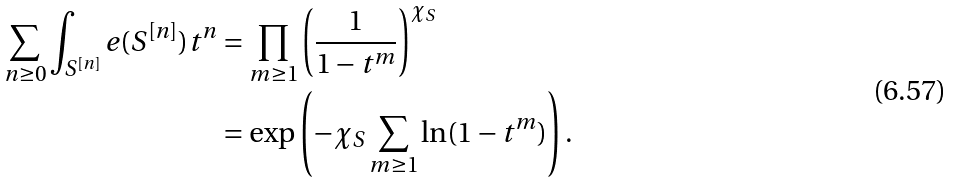<formula> <loc_0><loc_0><loc_500><loc_500>\sum _ { n \geq 0 } \int _ { S ^ { [ n ] } } e ( S ^ { [ n ] } ) t ^ { n } & = \prod _ { m \geq 1 } \left ( \frac { 1 } { 1 - t ^ { m } } \right ) ^ { \chi _ { S } } \\ & = \exp \left ( - \chi _ { S } \sum _ { m \geq 1 } \ln ( 1 - t ^ { m } ) \right ) .</formula> 